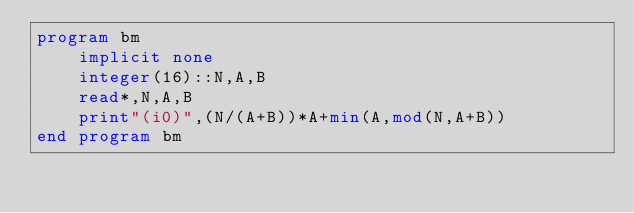<code> <loc_0><loc_0><loc_500><loc_500><_FORTRAN_>program bm
    implicit none
    integer(16)::N,A,B
    read*,N,A,B
    print"(i0)",(N/(A+B))*A+min(A,mod(N,A+B))
end program bm</code> 